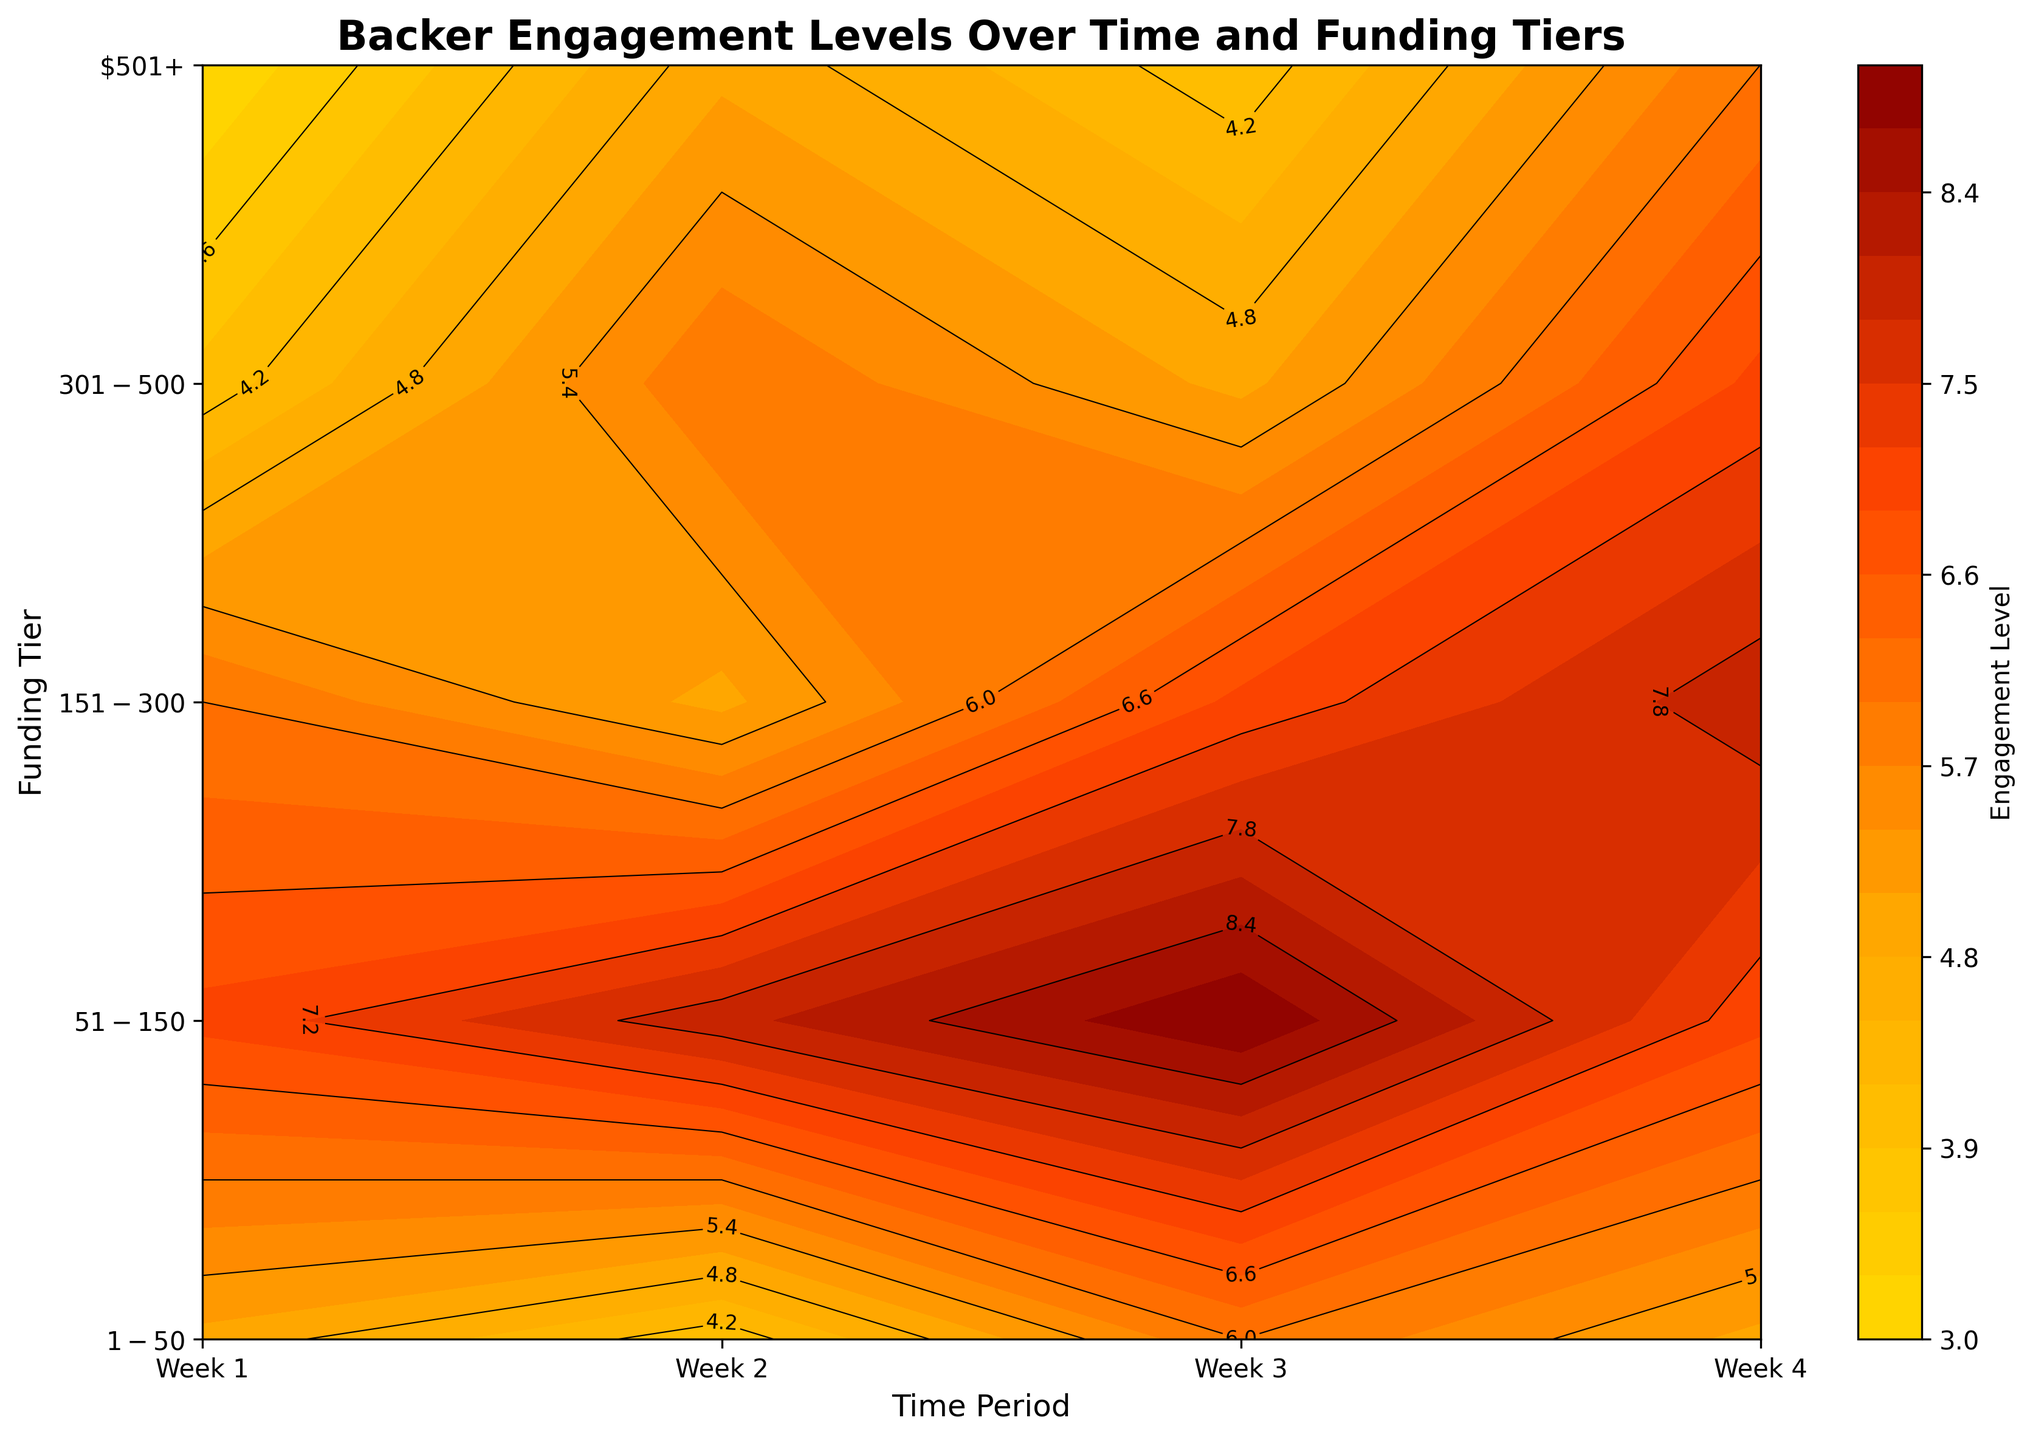What is the title of the plot? The title of the plot is located at the top of the figure and is usually larger and bolded for easy identification. It encapsulates the main theme or information the plot represents.
Answer: Backer Engagement Levels Over Time and Funding Tiers What are the labeled axes on the plot? The axes are typically labeled to provide context to what each dimension of the plot represents. The x-axis and y-axis labels can be found along the respective sides of the plot.
Answer: Time Period and Funding Tier What is the color at the highest Backer Engagement Level? The color representing the highest Backer Engagement Level can be identified in the contour plot, typically located on the color bar as the extreme end.
Answer: Deep Red Which week saw the highest engagement for the $151-$300 tier? Look at the intersection of the $151-$300 tier with the time periods. The contour labels will indicate the engagement levels; identify the highest value.
Answer: Week 4 How does engagement in the $51-$150 tier compare between Week 1 and Week 3? Locate the engagement levels for the $51-$150 tier at Week 1 and Week 3. Compare the numerical values labeled in the contour.
Answer: Week 3 has a higher engagement than Week 1 What trend can you observe in the $1-$50 tier over the four weeks? Trace the engagement levels across the $1-$50 tier from Week 1 to Week 4. Note any increases, decreases, or consistent patterns.
Answer: Fluctuating with no clear trend, ending same as it started Which funding tier shows the most consistent engagement level across all weeks? Analyze the contour labels across all four weeks for each funding tier. Identify the tier with the least variation in engagement levels.
Answer: $51-$150 What is the general relationship between funding tiers and Backer Engagement Level? Observe how engagement levels change as you move from lower to higher funding tiers, regardless of the time period.
Answer: Generally, higher funding tiers tend to have higher engagement levels In Week 2, which funding tier had the lowest engagement? Locate Week 2 along the x-axis and identify the funding tier with the lowest labeled engagement level in that time period.
Answer: $1-$50 How does the engagement level in Week 4 for the $501+ tier compare to Week 1 for the $151-$300 tier? Identify the engagement level for the $501+ tier in Week 4 and compare it to the engagement level for the $151-$300 tier in Week 1 by looking at their respective contour labels.
Answer: Both have the same engagement level 